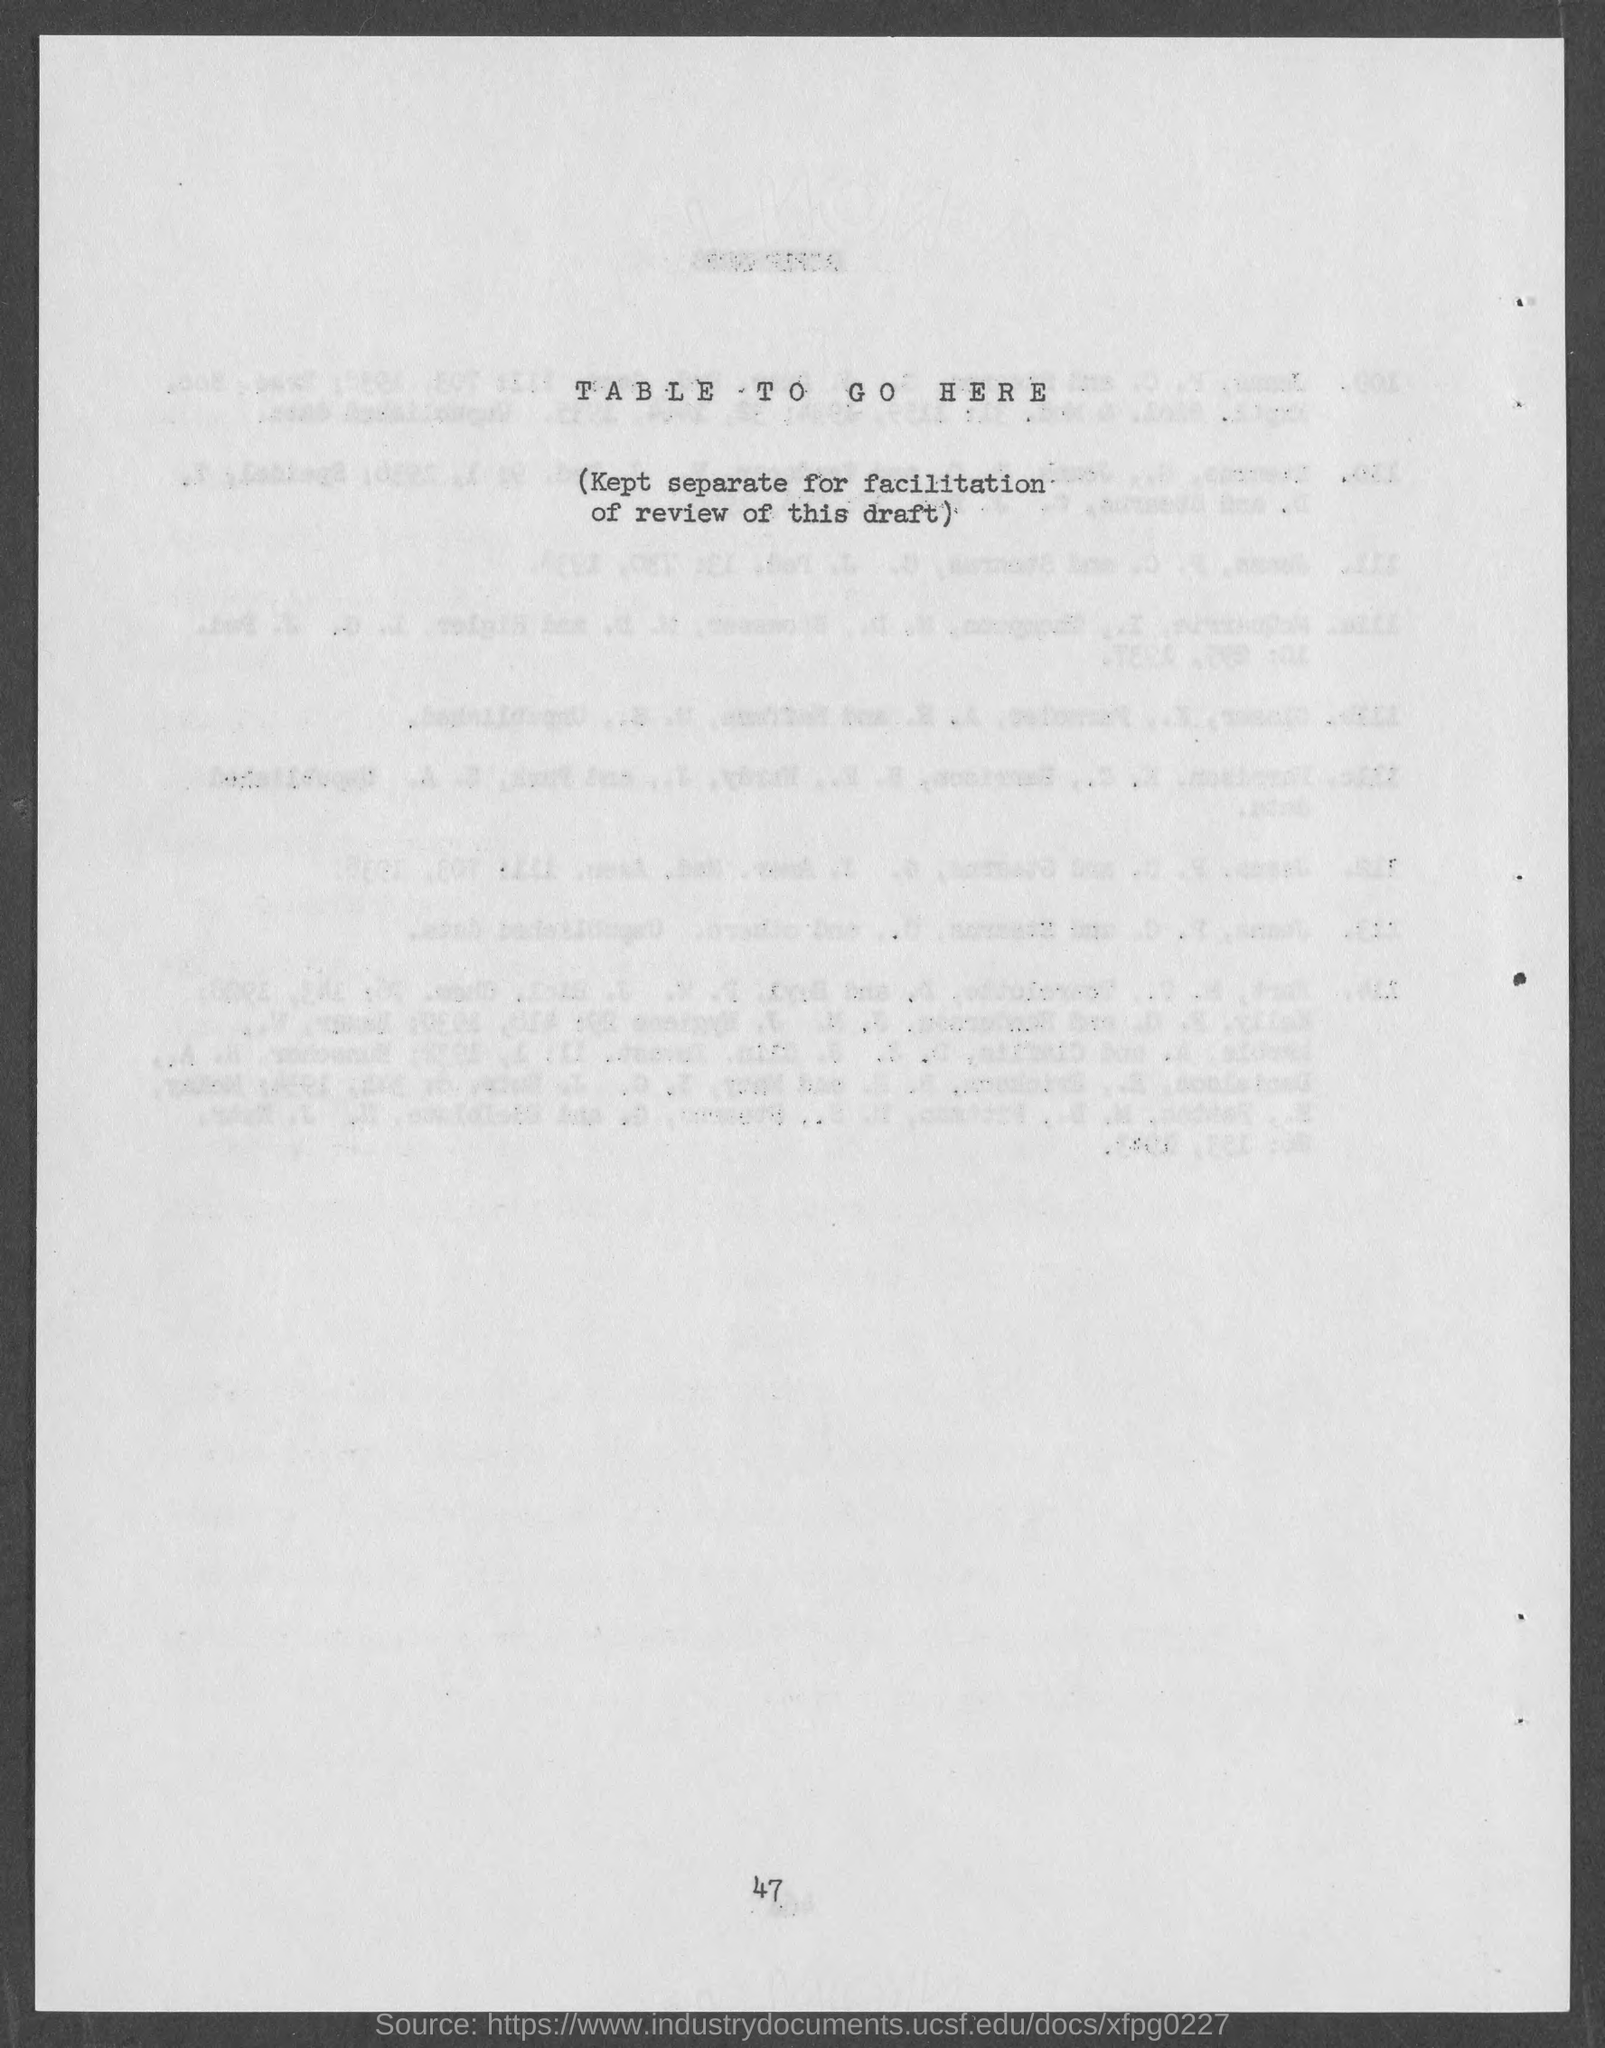What is the page number at bottom of the page?
Offer a very short reply. 47. 